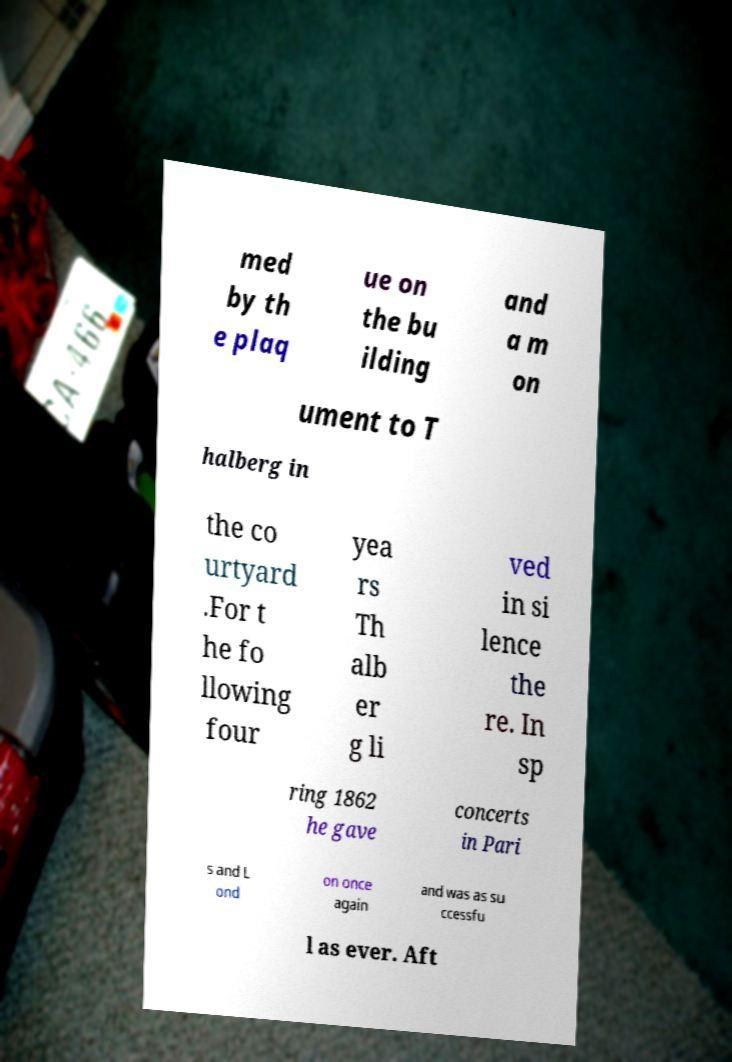Please read and relay the text visible in this image. What does it say? med by th e plaq ue on the bu ilding and a m on ument to T halberg in the co urtyard .For t he fo llowing four yea rs Th alb er g li ved in si lence the re. In sp ring 1862 he gave concerts in Pari s and L ond on once again and was as su ccessfu l as ever. Aft 